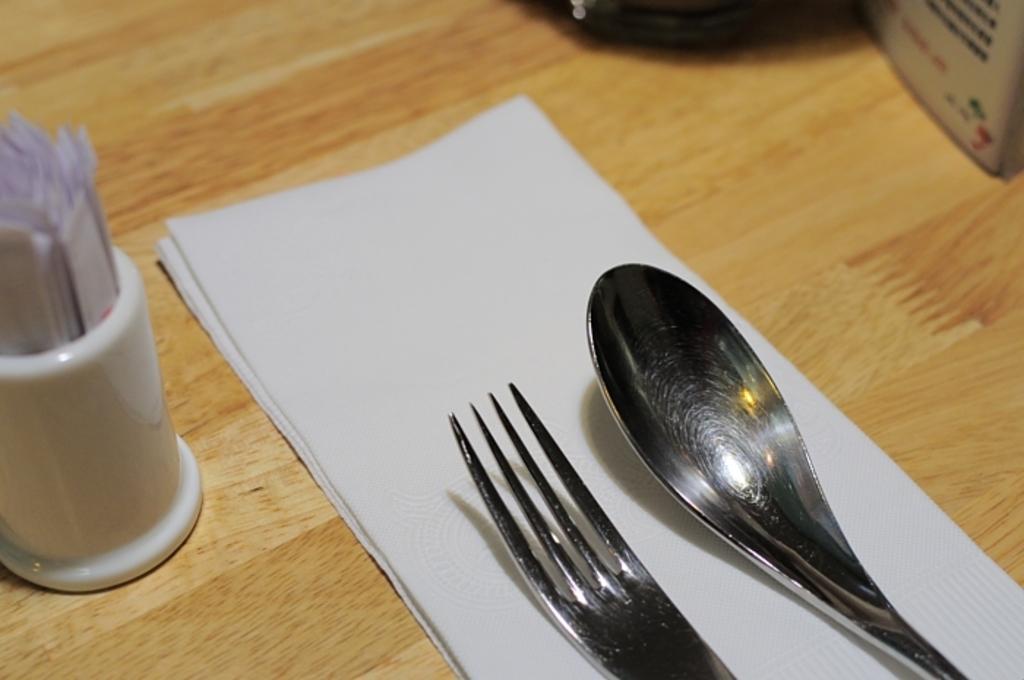In one or two sentences, can you explain what this image depicts? In the picture we can see a wooden table on it we can see some tissues with fork and spoon and beside it we can see a white color glass with some papers in it. 